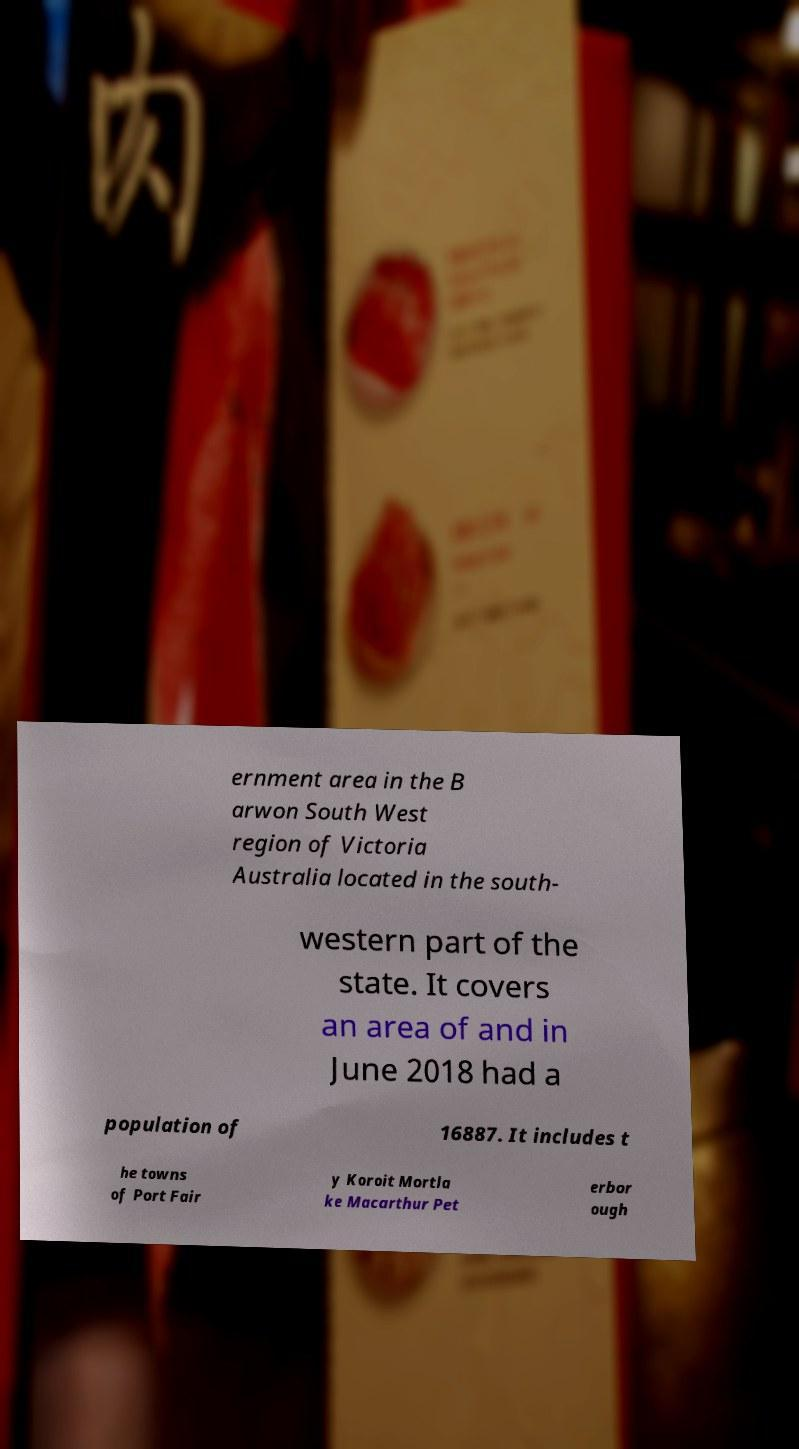There's text embedded in this image that I need extracted. Can you transcribe it verbatim? ernment area in the B arwon South West region of Victoria Australia located in the south- western part of the state. It covers an area of and in June 2018 had a population of 16887. It includes t he towns of Port Fair y Koroit Mortla ke Macarthur Pet erbor ough 